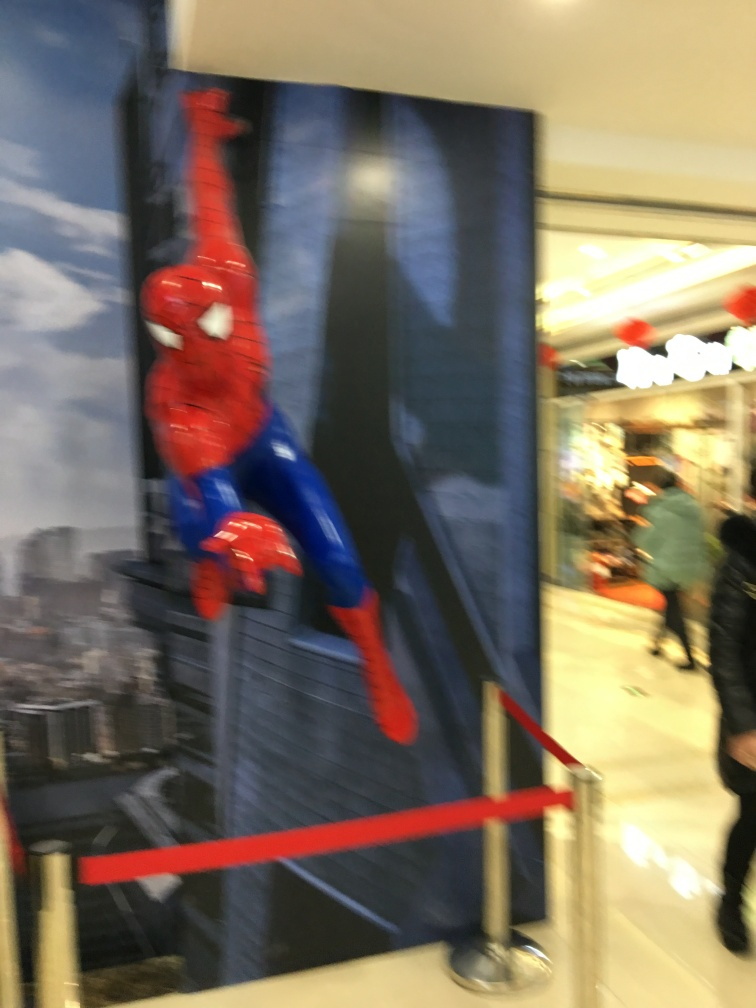What is the setting depicted in the background of this image? The background depicts an urban setting with numerous buildings that give the impression of a bustling cityscape, possibly representing a scene from a superhero story. 